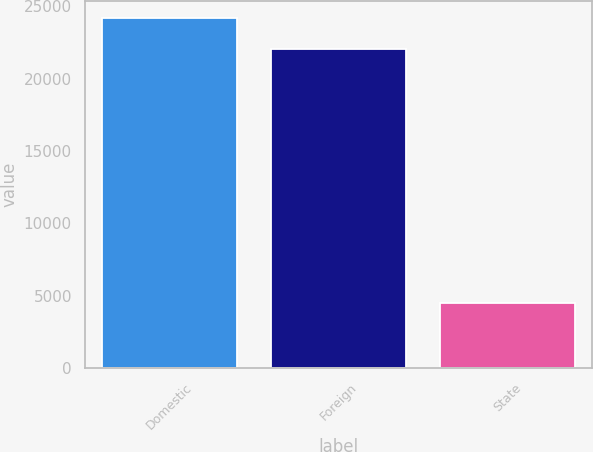<chart> <loc_0><loc_0><loc_500><loc_500><bar_chart><fcel>Domestic<fcel>Foreign<fcel>State<nl><fcel>24166<fcel>22037<fcel>4488<nl></chart> 